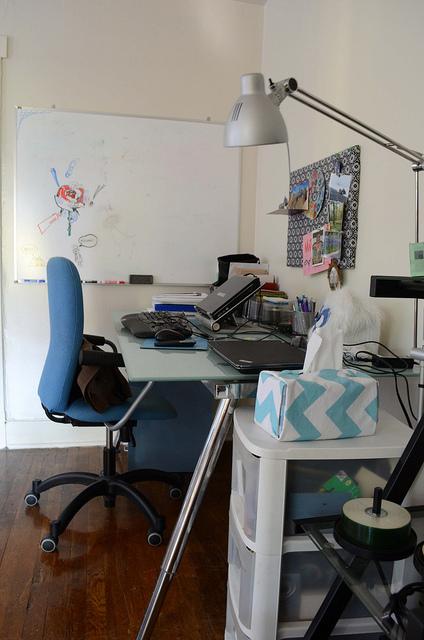Is this a home office?
Quick response, please. Yes. Does the chair match the carpet?
Quick response, please. No. What is the pattern on the kleenex box?
Write a very short answer. Zig zag. Is this someone's desk or vanity?
Concise answer only. Desk. What type of flooring is this?
Quick response, please. Wood. Which room is this?
Answer briefly. Office. 